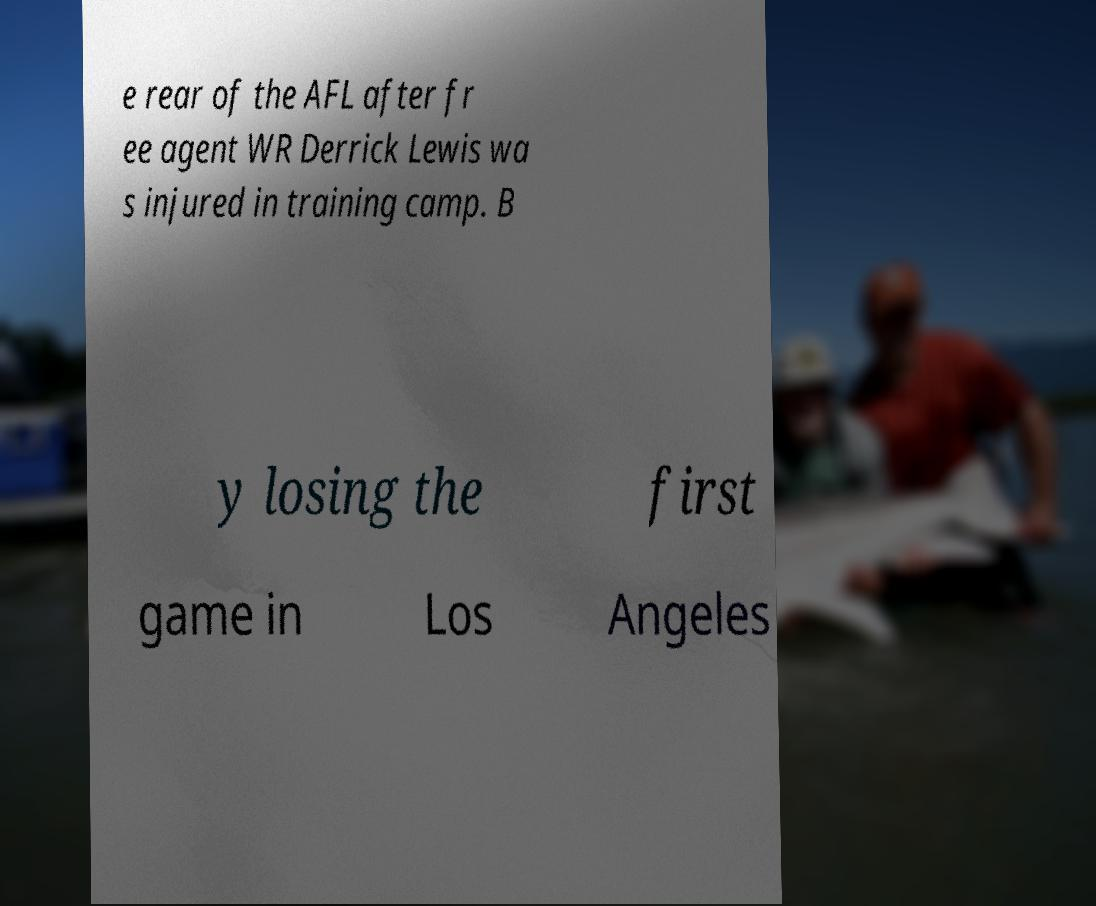What messages or text are displayed in this image? I need them in a readable, typed format. e rear of the AFL after fr ee agent WR Derrick Lewis wa s injured in training camp. B y losing the first game in Los Angeles 